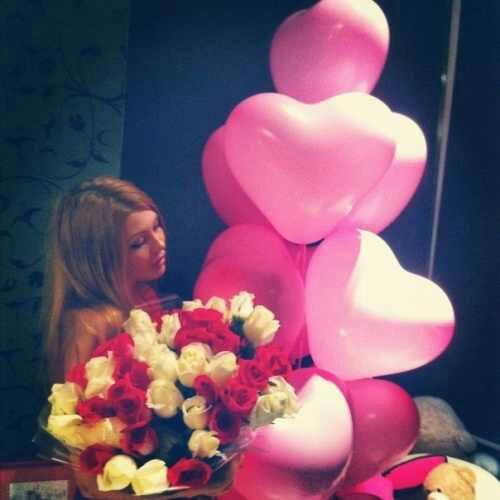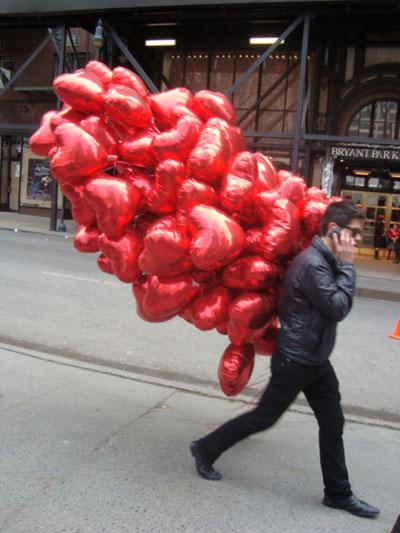The first image is the image on the left, the second image is the image on the right. Given the left and right images, does the statement "There is a heart shaped balloon in both images." hold true? Answer yes or no. Yes. The first image is the image on the left, the second image is the image on the right. Evaluate the accuracy of this statement regarding the images: "There is a man outside walking with at least ten red balloons.". Is it true? Answer yes or no. Yes. 